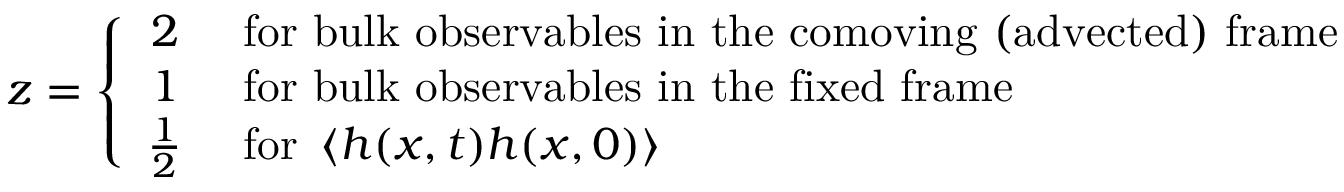<formula> <loc_0><loc_0><loc_500><loc_500>z = \left \{ \begin{array} { c l } { 2 } & { f o r b u l k o b s e r v a b l e s i n t h e c o m o v i n g ( a d v e c t e d ) f r a m e } \\ { 1 } & { f o r b u l k o b s e r v a b l e s i n t h e f i x e d f r a m e } \\ { \frac { 1 } { 2 } } & { f o r \left < h ( x , t ) h ( x , 0 ) \right > } \end{array}</formula> 